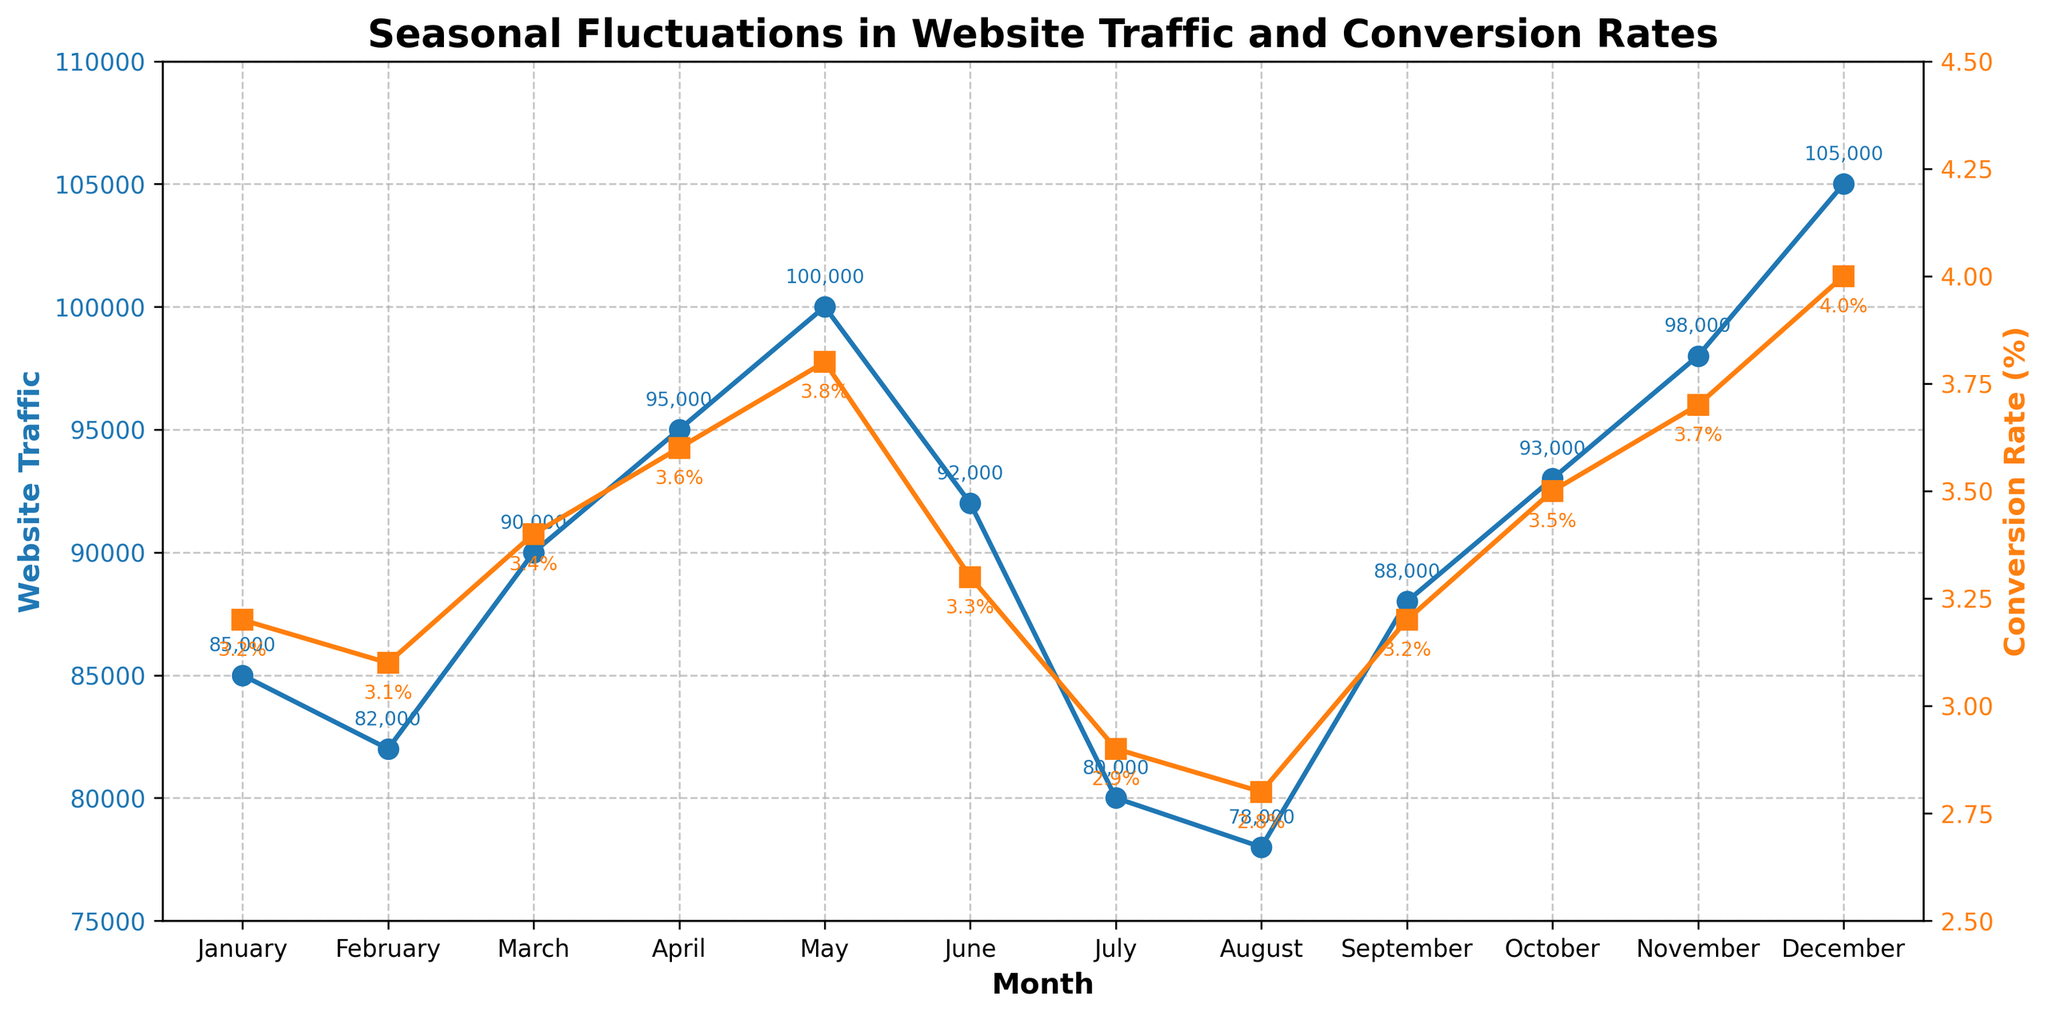Which month has the highest website traffic? To find the month with the highest website traffic, look for the highest value in the "Website Traffic" plot. The highest point in the traffic line corresponds to December with a value of 105,000.
Answer: December Which month has the lowest conversion rate? To determine the month with the lowest conversion rate, look for the lowest value in the "Conversion Rate" plot. The lowest point is in August with a conversion rate of 2.8%.
Answer: August What is the difference in website traffic between May and July? Find and subtract the website traffic value of July from May. May has 100,000 and July has 80,000 in website traffic. The difference is 100,000 - 80,000 = 20,000.
Answer: 20,000 Which month shows the greatest drop in conversion rate compared to the previous month? Evaluate month-by-month changes in the conversion rate plot. The greatest decrease happens between May (3.8%) and June (3.3%), with a drop of 0.5%.
Answer: June How much higher is the conversion rate in December compared to January? Compare the conversion rates of December and January by subtracting January’s rate from December’s. December has a conversion rate of 4.0%, and January has 3.2%, so the difference is 4.0 - 3.2 = 0.8%.
Answer: 0.8% Which period shows an increasing trend in both website traffic and conversion rates? Identify the interval where both lines trend upwards. From March to May, both website traffic and conversion rates increase continuously.
Answer: March to May What is the average website traffic from June to August? Sum the website traffic values for June (92,000), July (80,000), and August (78,000), then divide by 3. The sum is 250,000, and the average is 250,000 / 3 ≈ 83,333.
Answer: 83,333 Are there any months where conversion rate and website traffic both peak? Conversion rate peaks in December, and website traffic also peaks in December. Hence, both peaks occur in December.
Answer: December 